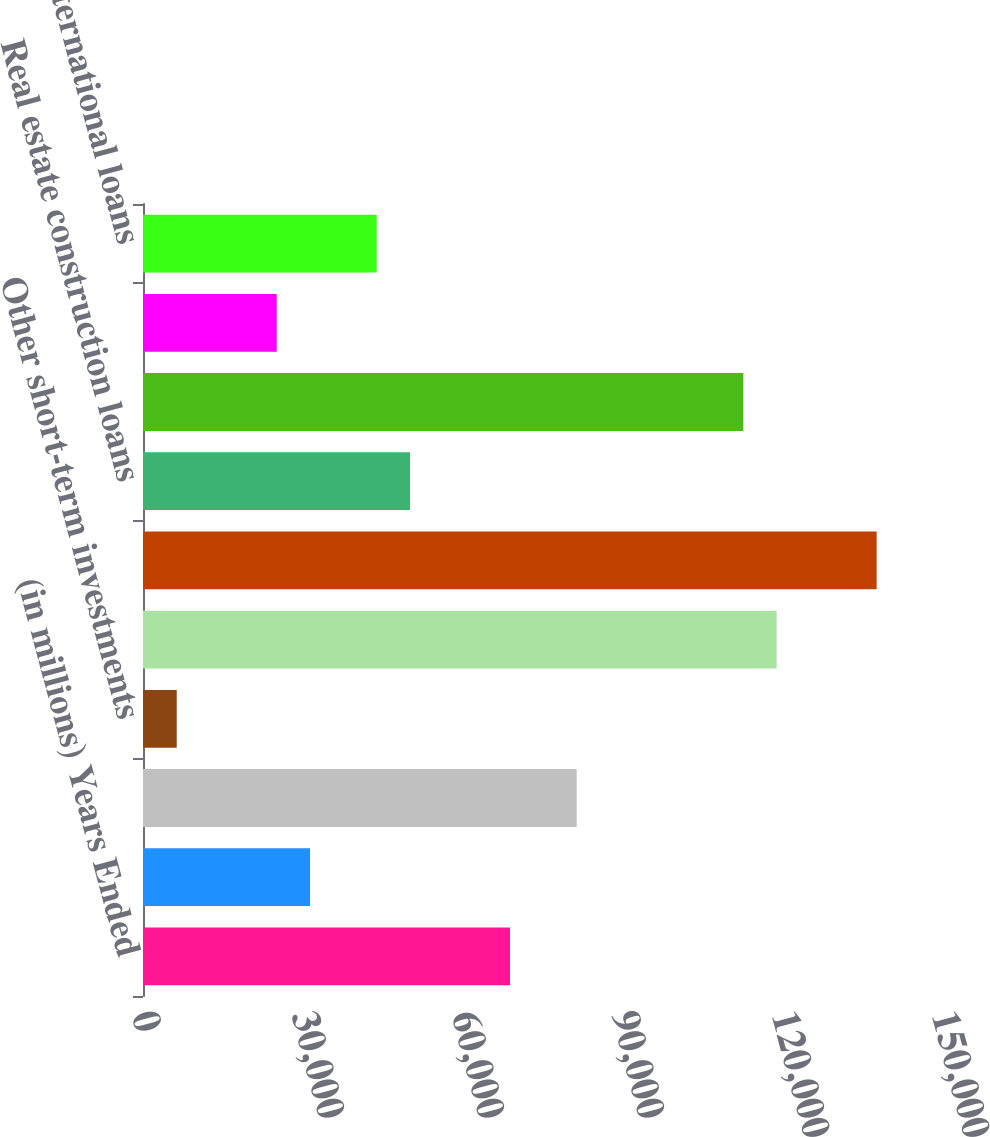<chart> <loc_0><loc_0><loc_500><loc_500><bar_chart><fcel>(in millions) Years Ended<fcel>Cash and due from banks<fcel>Interest-bearing deposits with<fcel>Other short-term investments<fcel>Investment securities<fcel>Commercial loans<fcel>Real estate construction loans<fcel>Commercial mortgage loans<fcel>Lease financing<fcel>International loans<nl><fcel>68818.3<fcel>31322.5<fcel>81316.9<fcel>6325.3<fcel>118813<fcel>137561<fcel>50070.4<fcel>112563<fcel>25073.2<fcel>43821.1<nl></chart> 